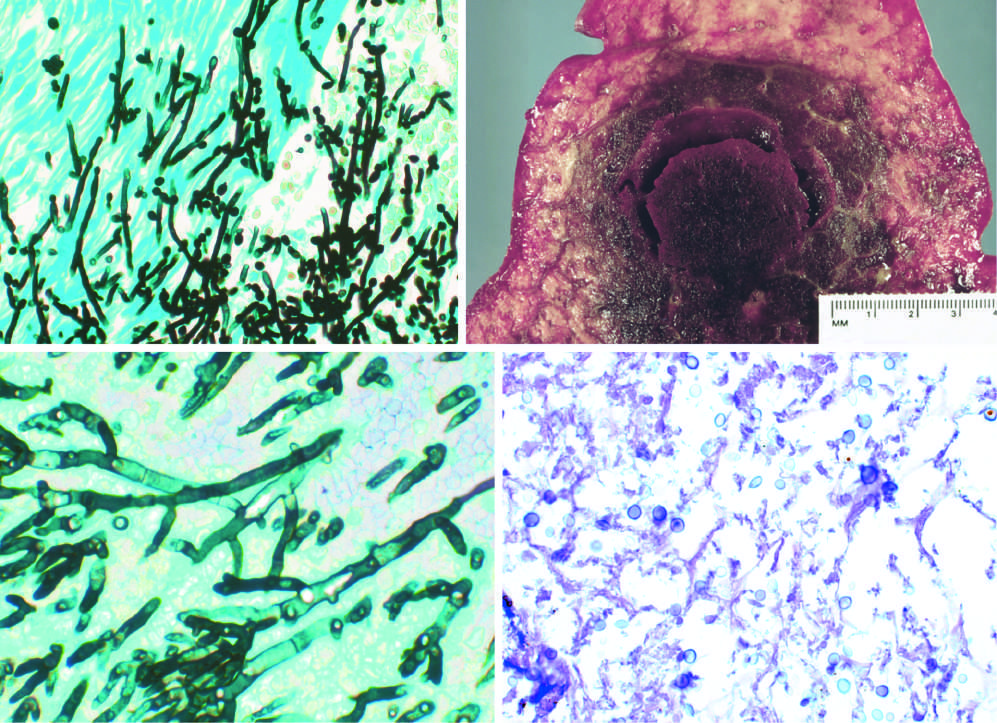how does gomori methenamine-silver (gms) stain show septate hyphae?
Answer the question using a single word or phrase. With acute-angle branching 